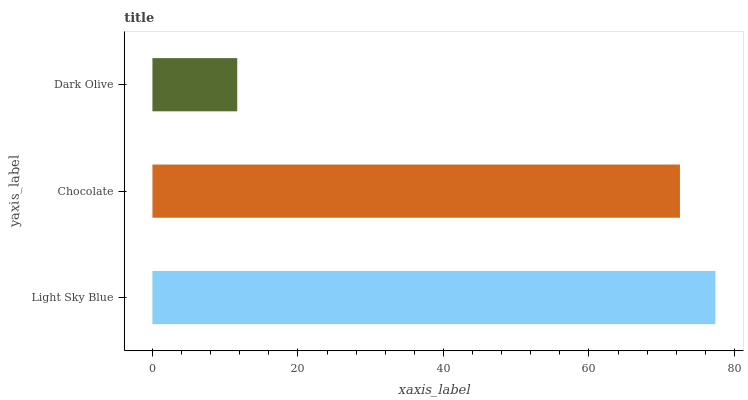Is Dark Olive the minimum?
Answer yes or no. Yes. Is Light Sky Blue the maximum?
Answer yes or no. Yes. Is Chocolate the minimum?
Answer yes or no. No. Is Chocolate the maximum?
Answer yes or no. No. Is Light Sky Blue greater than Chocolate?
Answer yes or no. Yes. Is Chocolate less than Light Sky Blue?
Answer yes or no. Yes. Is Chocolate greater than Light Sky Blue?
Answer yes or no. No. Is Light Sky Blue less than Chocolate?
Answer yes or no. No. Is Chocolate the high median?
Answer yes or no. Yes. Is Chocolate the low median?
Answer yes or no. Yes. Is Dark Olive the high median?
Answer yes or no. No. Is Light Sky Blue the low median?
Answer yes or no. No. 